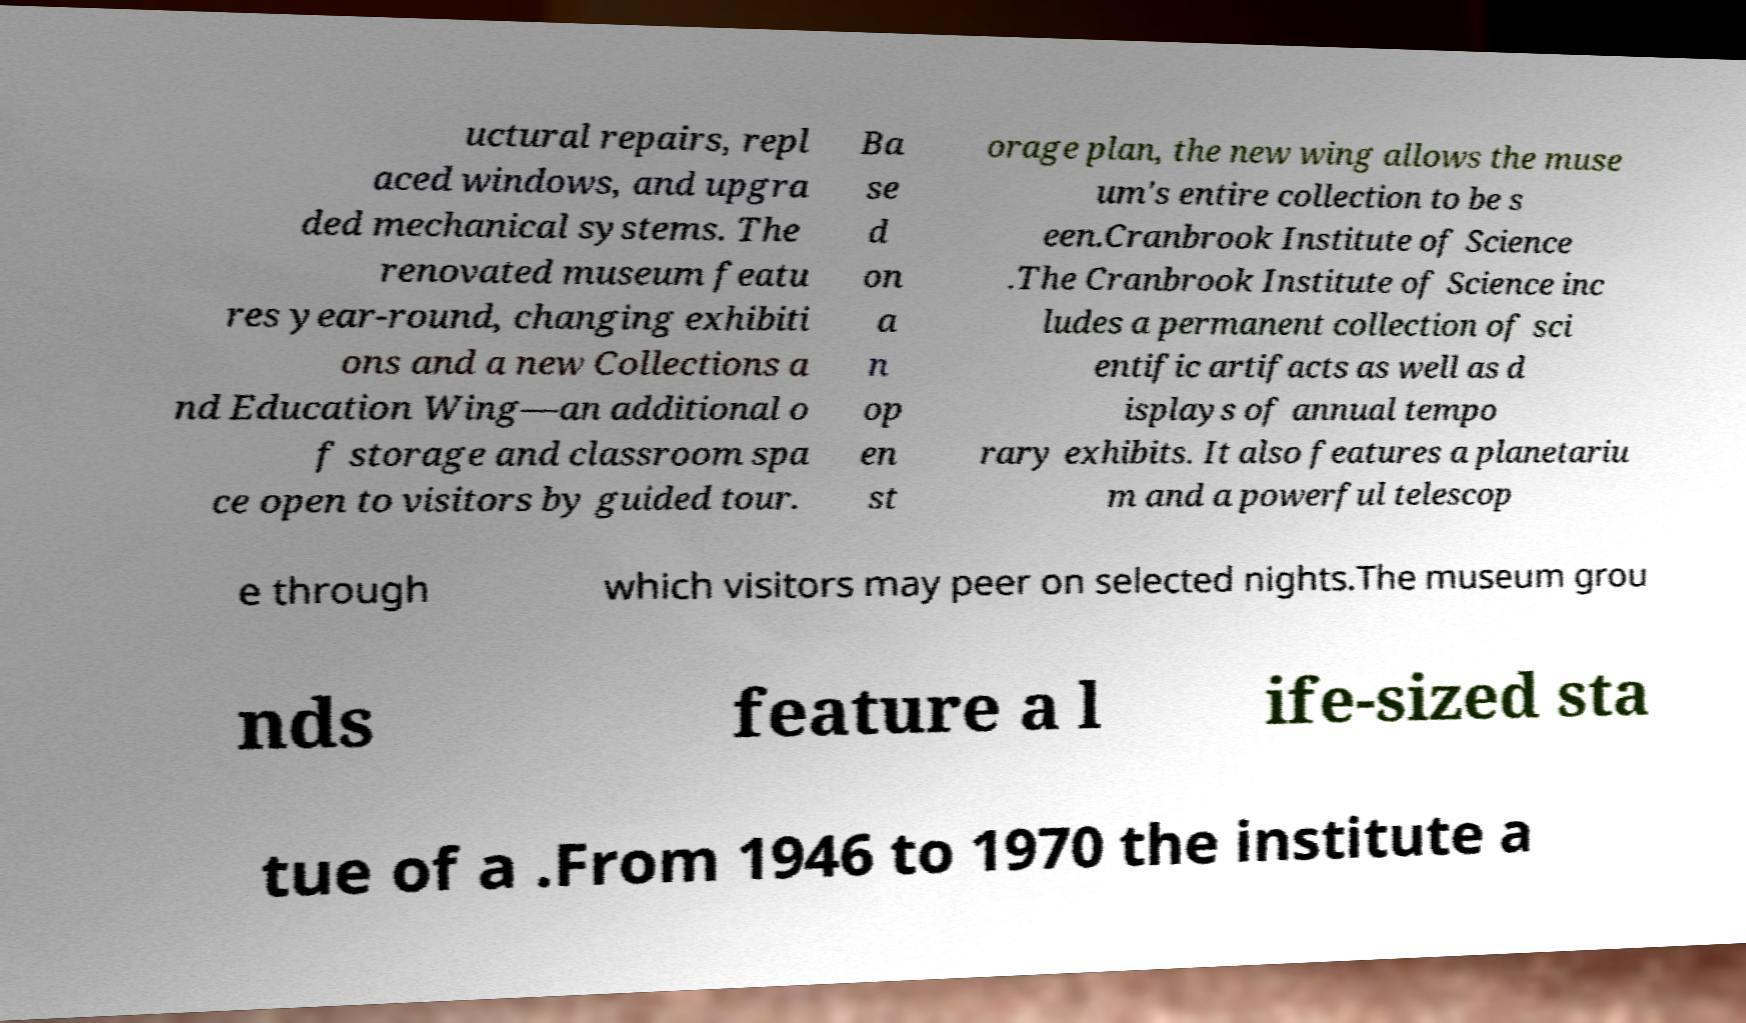Please identify and transcribe the text found in this image. uctural repairs, repl aced windows, and upgra ded mechanical systems. The renovated museum featu res year-round, changing exhibiti ons and a new Collections a nd Education Wing—an additional o f storage and classroom spa ce open to visitors by guided tour. Ba se d on a n op en st orage plan, the new wing allows the muse um's entire collection to be s een.Cranbrook Institute of Science .The Cranbrook Institute of Science inc ludes a permanent collection of sci entific artifacts as well as d isplays of annual tempo rary exhibits. It also features a planetariu m and a powerful telescop e through which visitors may peer on selected nights.The museum grou nds feature a l ife-sized sta tue of a .From 1946 to 1970 the institute a 